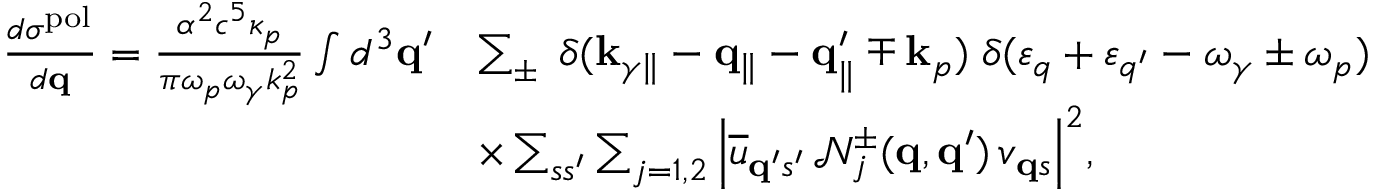Convert formula to latex. <formula><loc_0><loc_0><loc_500><loc_500>\begin{array} { r l } { \frac { d \sigma ^ { p o l } } { d { q } } = \frac { \alpha ^ { 2 } c ^ { 5 } \kappa _ { p } } { \pi \omega _ { p } \omega _ { \gamma } k _ { p } ^ { 2 } } \int d ^ { 3 } { q } ^ { \prime } } & { \sum _ { \pm } \, \delta ( { k } _ { \gamma \| } - { q } _ { \| } - { q } _ { \| } ^ { \prime } \mp { k } _ { p } ) \, \delta ( \varepsilon _ { q } + \varepsilon _ { q ^ { \prime } } - \omega _ { \gamma } \pm \omega _ { p } ) } \\ & { \times \sum _ { s s ^ { \prime } } \sum _ { j = 1 , 2 } \left | \overline { u } _ { { q } ^ { \prime } s ^ { \prime } } \, \mathcal { N } _ { j } ^ { \pm } ( { q } , { q } ^ { \prime } ) \, v _ { { q } s } \right | ^ { 2 } , } \end{array}</formula> 